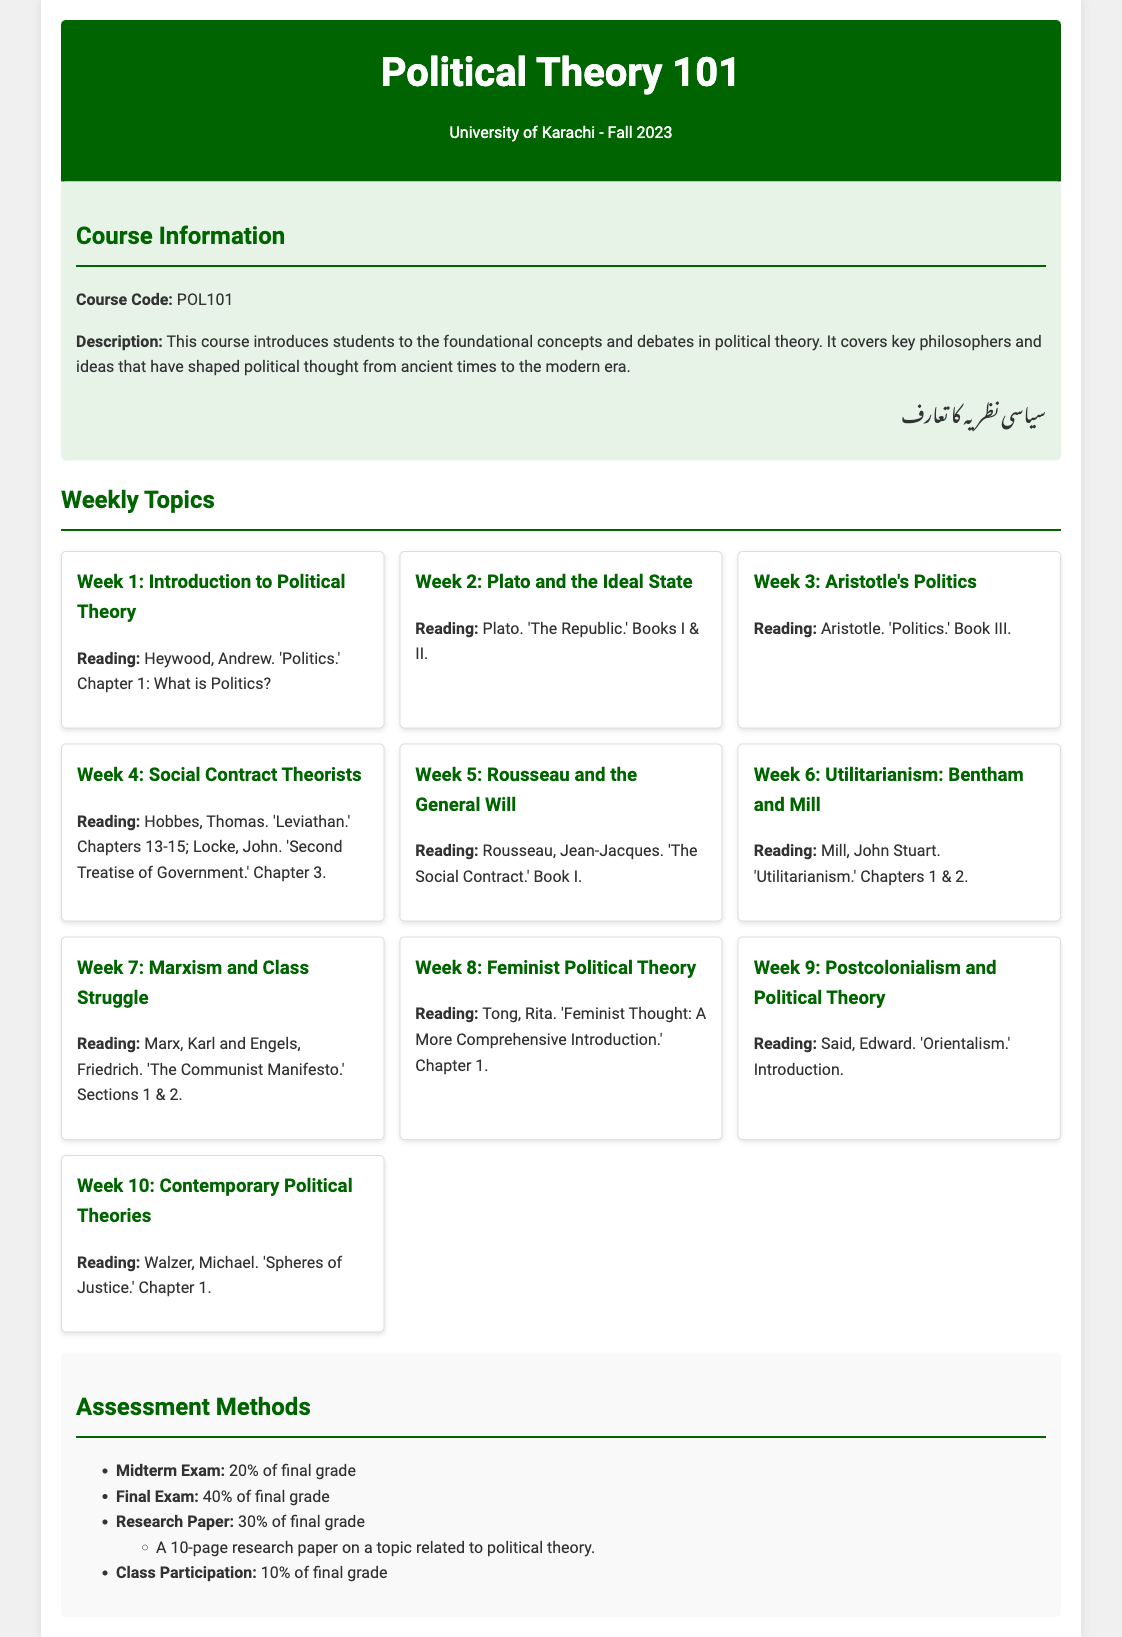What is the course code? The course code is mentioned in the course information section.
Answer: POL101 Who is the author of the reading for Week 4? The reading for Week 4 includes works by Hobbes and Locke, both mentioned as authors.
Answer: Hobbes What percentage of the final grade does the Final Exam account for? The percentage for each assessment method is specified in the assessment methods section.
Answer: 40% Which philosopher's ideas are discussed in Week 6? The topic of Week 6 focuses on the ideas of Utilitarianism, specifically associated with Bentham and Mill.
Answer: Bentham What is the title of the book read in Week 2? The title of the book for Week 2 is specified along with the reading sections.
Answer: The Republic How many weeks are covered in the syllabus? The number of weekly topics is indicated in the document.
Answer: 10 What is the assessment method that involves class interaction? The document details various assessment methods, including participation.
Answer: Class Participation In which week is Feminist Political Theory discussed? The week number for Feminist Political Theory is clearly stated in the weekly topics section.
Answer: Week 8 